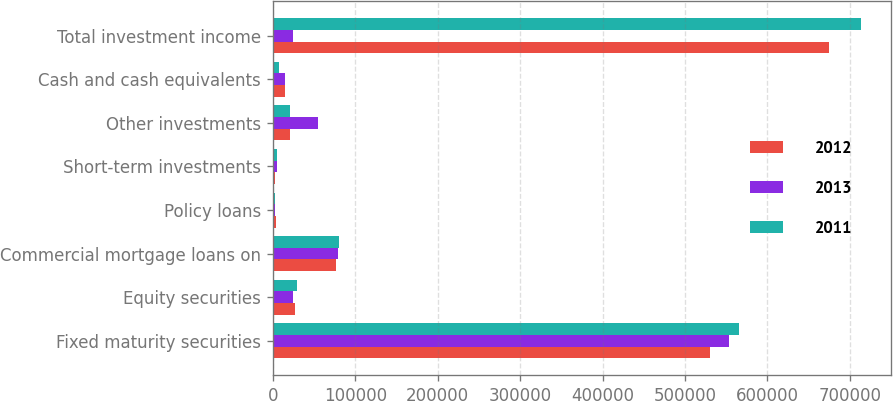Convert chart to OTSL. <chart><loc_0><loc_0><loc_500><loc_500><stacked_bar_chart><ecel><fcel>Fixed maturity securities<fcel>Equity securities<fcel>Commercial mortgage loans on<fcel>Policy loans<fcel>Short-term investments<fcel>Other investments<fcel>Cash and cash equivalents<fcel>Total investment income<nl><fcel>2012<fcel>530144<fcel>27013<fcel>76665<fcel>3426<fcel>2156<fcel>20573<fcel>14679<fcel>674656<nl><fcel>2013<fcel>553668<fcel>24771<fcel>79108<fcel>3204<fcel>4889<fcel>54581<fcel>15323<fcel>24771<nl><fcel>2011<fcel>565486<fcel>29645<fcel>80903<fcel>3102<fcel>5351<fcel>21326<fcel>7838<fcel>713651<nl></chart> 